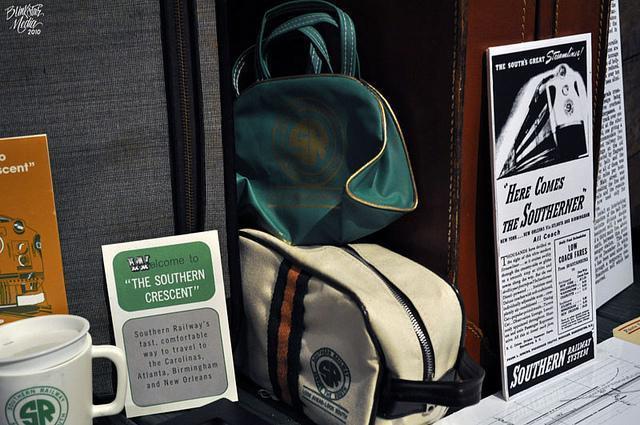What mode of transportation is The Southerner?
Choose the right answer and clarify with the format: 'Answer: answer
Rationale: rationale.'
Options: Truck, train, bus, van. Answer: train.
Rationale: The southerner is named as a railway. 